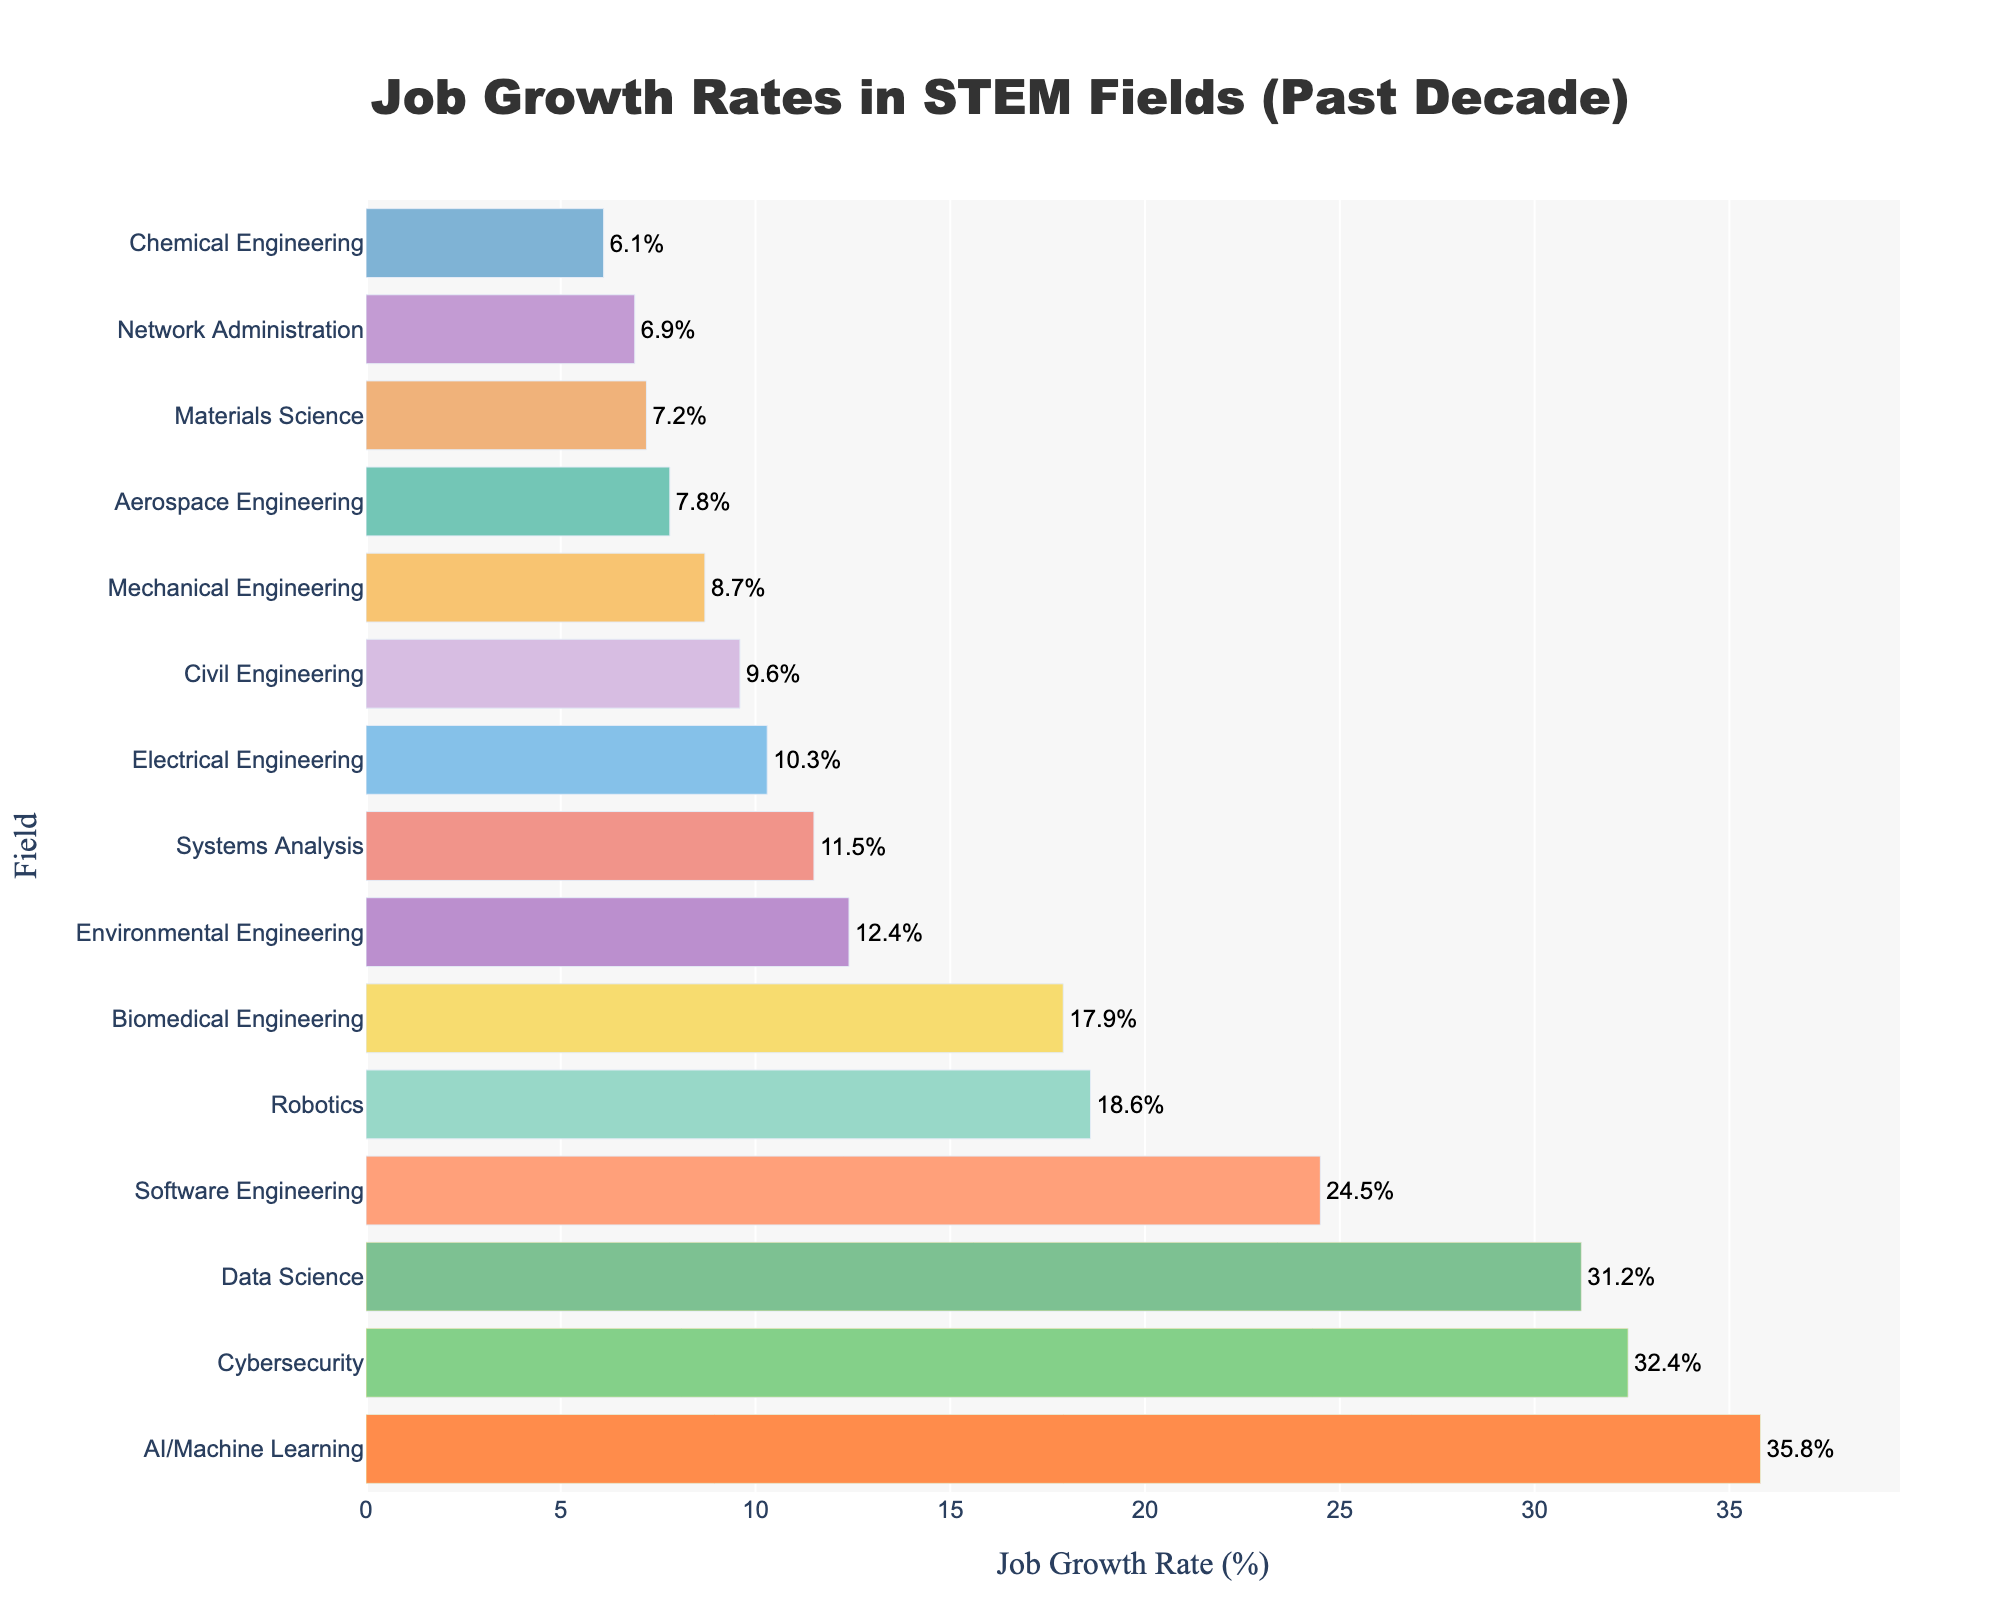Which STEM field has the highest job growth rate? The highest bar represents the AI/Machine Learning field with a job growth rate of 35.8%.
Answer: AI/Machine Learning Which three fields have the top job growth rates? The top three bars, highlighted by the golden rectangles, are for AI/Machine Learning (35.8%), Cybersecurity (32.4%), and Data Science (31.2%).
Answer: AI/Machine Learning, Cybersecurity, Data Science What is the difference in job growth rate between Software Engineering and Electrical Engineering? Software Engineering has a growth rate of 24.5%, and Electrical Engineering has a growth rate of 10.3%. The difference is calculated as 24.5% - 10.3% = 14.2%.
Answer: 14.2% Which STEM field has the lowest job growth rate? The shortest bar represents the Chemical Engineering field with a job growth rate of 6.1%.
Answer: Chemical Engineering How many fields have a job growth rate greater than 20%? The bars that exceed 20% are for Software Engineering (24.5%), Data Science (31.2%), Cybersecurity (32.4%), and AI/Machine Learning (35.8%), counting up to four fields.
Answer: 4 What is the average job growth rate of Civil Engineering, Environmental Engineering, and Biomedical Engineering? The job growth rates are Civil Engineering (9.6%), Environmental Engineering (12.4%), and Biomedical Engineering (17.9%). The average is calculated as (9.6% + 12.4% + 17.9%) / 3 = 13.3%.
Answer: 13.3% Which field has a higher job growth rate, Mechanical Engineering, or Robotics? The bar for Robotics (18.6%) is higher than the bar for Mechanical Engineering (8.7%).
Answer: Robotics What is the combined job growth rate of Network Administration and Systems Analysis? The job growth rates are Network Administration (6.9%) and Systems Analysis (11.5%). The combined rate is 6.9% + 11.5% = 18.4%.
Answer: 18.4% What can you infer about the job growth rate trend in AI/Machine Learning field from the bar chart? The bar for AI/Machine Learning is the highest, indicating it has the most significant job growth rate among the listed fields, suggesting a strong positive trend in that field over the past decade.
Answer: Significant trend in growth 